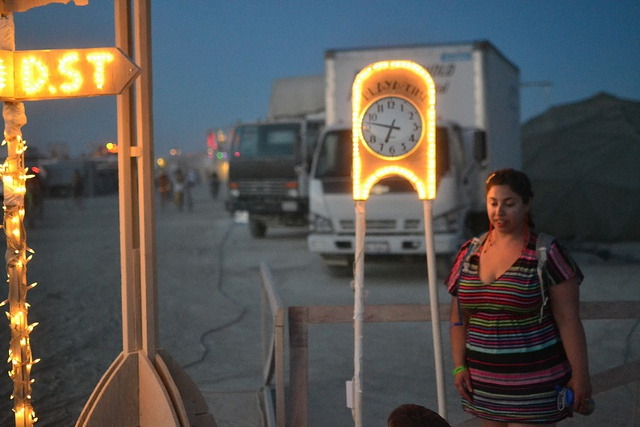Describe the objects in this image and their specific colors. I can see people in maroon, black, and gray tones, truck in maroon, gray, blue, and black tones, truck in maroon, gray, black, and purple tones, clock in maroon and gray tones, and backpack in maroon, black, gray, and brown tones in this image. 